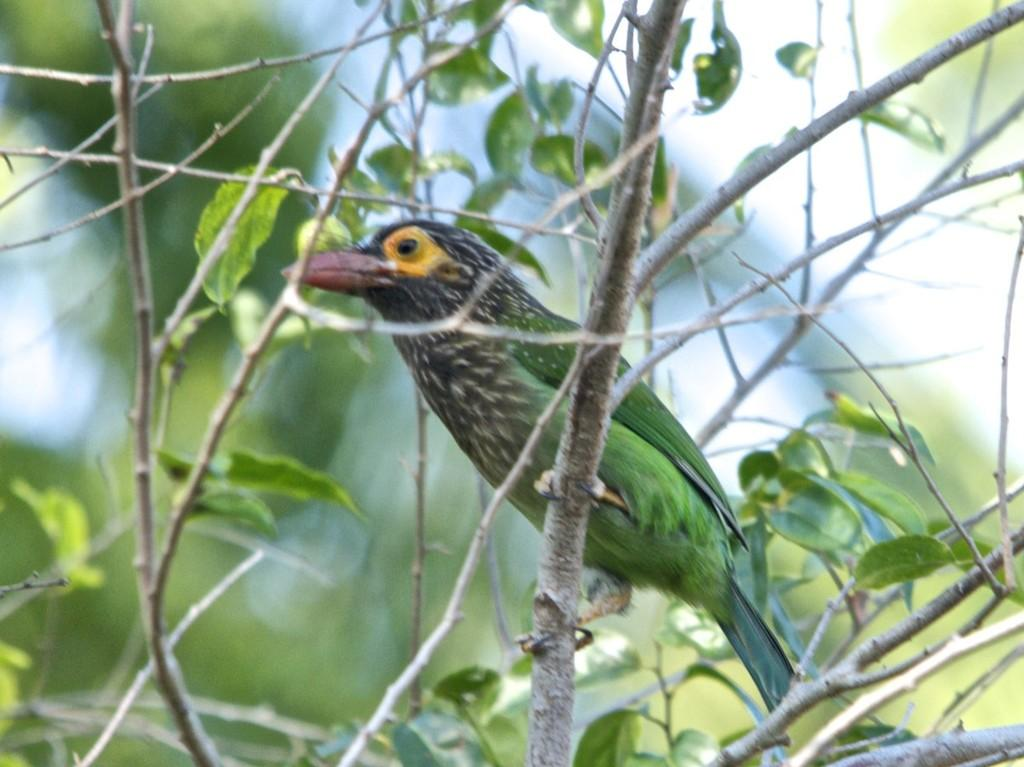What type of animal is in the image? There is a bird in the image. Where is the bird located? The bird is on a tree. Can you describe the background of the image be clearly seen? No, the background of the image is blurred. What type of truck is visible in the image? There is no truck present in the image; it features a bird on a tree with a blurred background. 